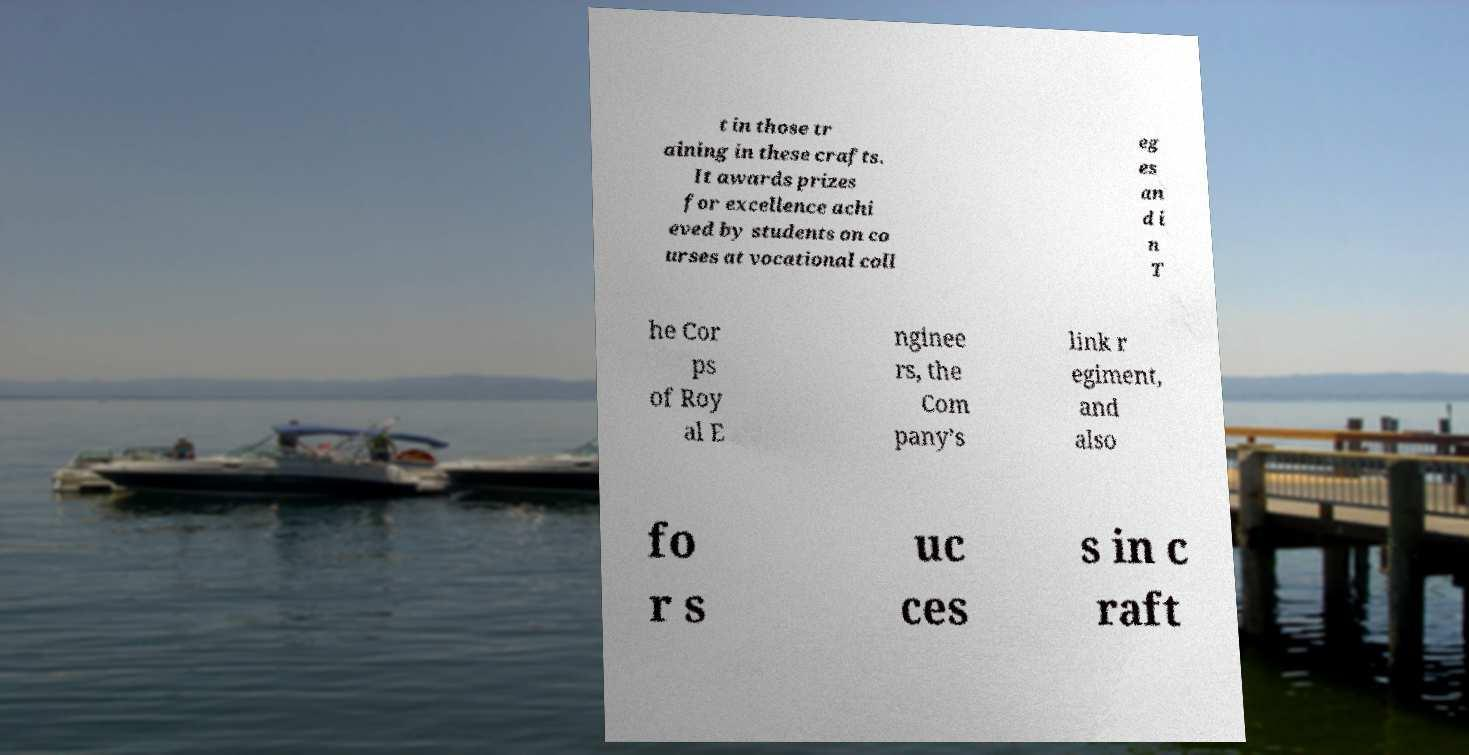What messages or text are displayed in this image? I need them in a readable, typed format. t in those tr aining in these crafts. It awards prizes for excellence achi eved by students on co urses at vocational coll eg es an d i n T he Cor ps of Roy al E nginee rs, the Com pany’s link r egiment, and also fo r s uc ces s in c raft 